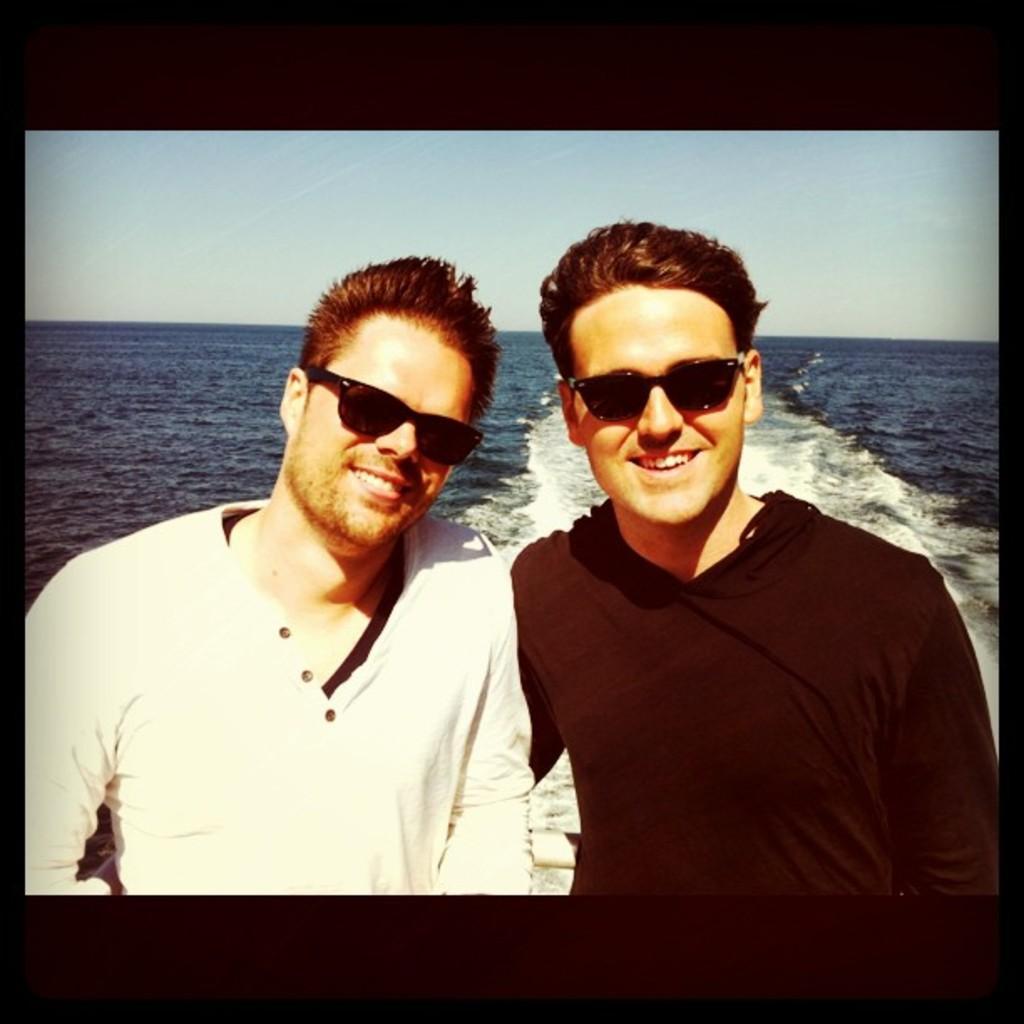Can you describe this image briefly? In this image, we can see two persons wearing clothes and sunglasses. There is a sea in the middle of the image. There is a sky at the top of the image. 